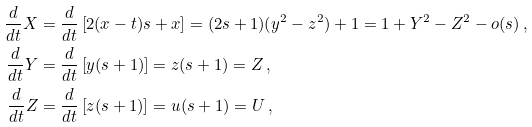Convert formula to latex. <formula><loc_0><loc_0><loc_500><loc_500>\frac { d } { d t } X & = \frac { d } { d t } \left [ 2 ( x - t ) s + x \right ] = ( 2 s + 1 ) ( y ^ { 2 } - z ^ { 2 } ) + 1 = 1 + Y ^ { 2 } - Z ^ { 2 } - o ( s ) \, , \\ \frac { d } { d t } Y & = \frac { d } { d t } \left [ y ( s + 1 ) \right ] = z ( s + 1 ) = Z \, , \\ \frac { d } { d t } Z & = \frac { d } { d t } \left [ z ( s + 1 ) \right ] = u ( s + 1 ) = U \, ,</formula> 